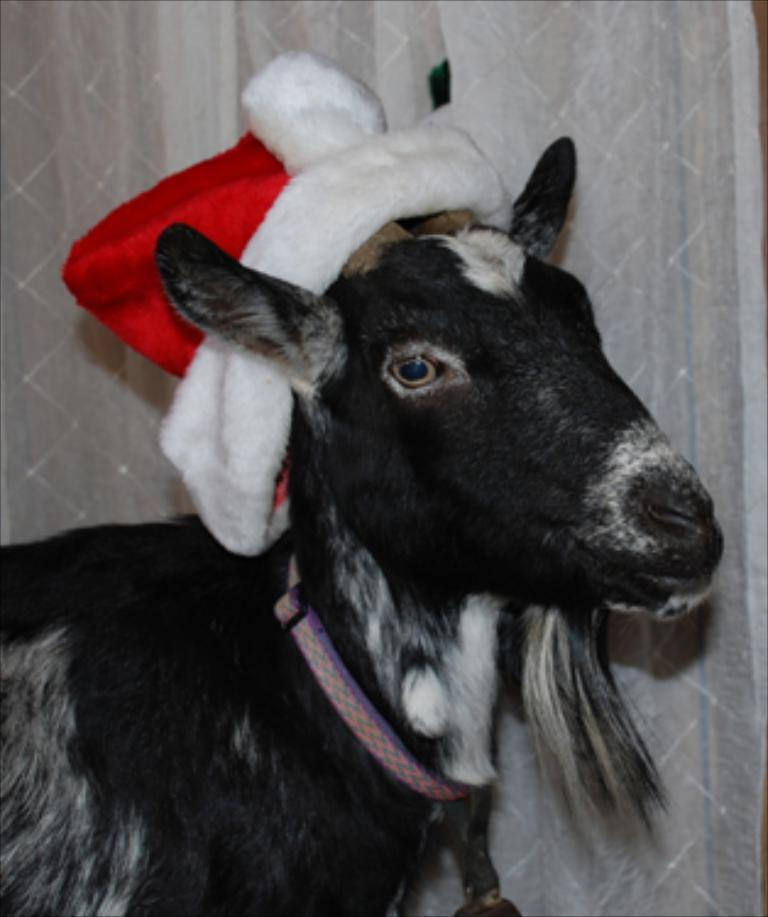What animal is present in the image? There is a goat in the image. What is the goat wearing on its head? The goat is wearing a Christmas hat. What is tied around the goat's neck? The goat has a belt around its neck. What can be seen in the background of the image? There is a curtain in the background of the image. What color is the curtain? The curtain is white in color. What type of tin can be seen in the image? There is no tin present in the image. How many friends are visible in the image? There are no friends visible in the image; it features a goat. What type of structure is shown in the image? The image does not depict a structure; it features a goat with a Christmas hat and a curtain in the background. 